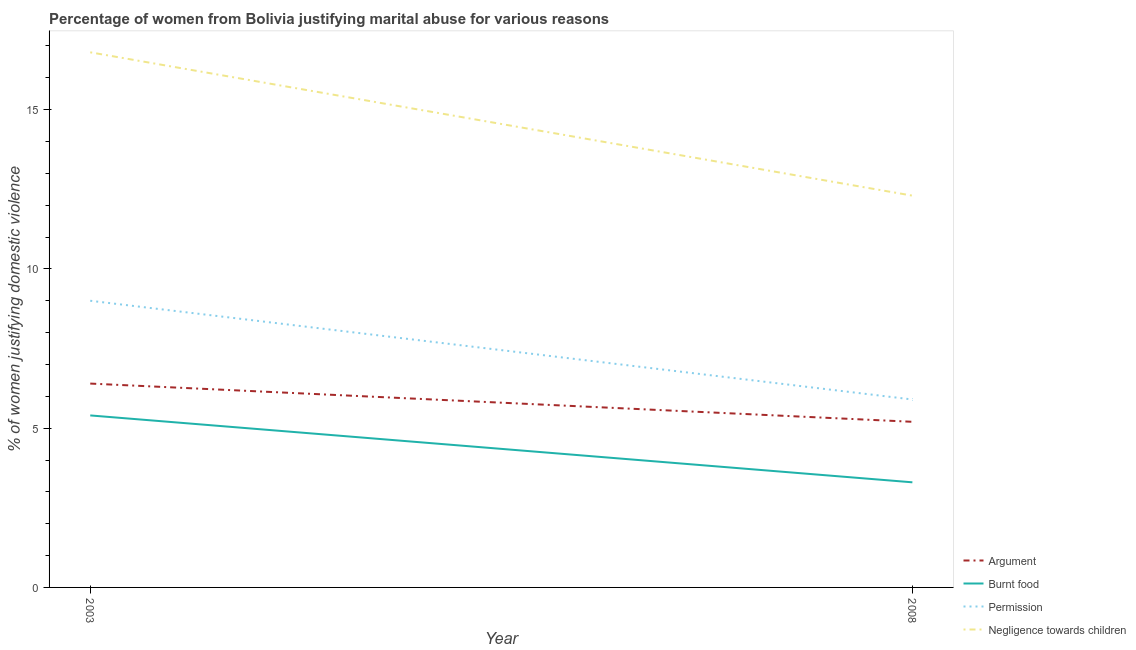How many different coloured lines are there?
Your answer should be very brief. 4. What is the percentage of women justifying abuse in the case of an argument in 2003?
Make the answer very short. 6.4. Across all years, what is the minimum percentage of women justifying abuse for showing negligence towards children?
Your answer should be compact. 12.3. What is the total percentage of women justifying abuse for showing negligence towards children in the graph?
Ensure brevity in your answer.  29.1. What is the difference between the percentage of women justifying abuse for going without permission in 2003 and that in 2008?
Your answer should be compact. 3.1. What is the difference between the percentage of women justifying abuse for going without permission in 2008 and the percentage of women justifying abuse for showing negligence towards children in 2003?
Provide a short and direct response. -10.9. What is the average percentage of women justifying abuse for showing negligence towards children per year?
Provide a short and direct response. 14.55. In the year 2003, what is the difference between the percentage of women justifying abuse for going without permission and percentage of women justifying abuse for burning food?
Give a very brief answer. 3.6. What is the ratio of the percentage of women justifying abuse for going without permission in 2003 to that in 2008?
Provide a short and direct response. 1.53. In how many years, is the percentage of women justifying abuse for burning food greater than the average percentage of women justifying abuse for burning food taken over all years?
Your response must be concise. 1. Is it the case that in every year, the sum of the percentage of women justifying abuse for going without permission and percentage of women justifying abuse for burning food is greater than the sum of percentage of women justifying abuse for showing negligence towards children and percentage of women justifying abuse in the case of an argument?
Ensure brevity in your answer.  No. Is the percentage of women justifying abuse for burning food strictly greater than the percentage of women justifying abuse for showing negligence towards children over the years?
Give a very brief answer. No. Does the graph contain any zero values?
Ensure brevity in your answer.  No. Does the graph contain grids?
Provide a succinct answer. No. Where does the legend appear in the graph?
Offer a very short reply. Bottom right. How many legend labels are there?
Your answer should be compact. 4. How are the legend labels stacked?
Your answer should be very brief. Vertical. What is the title of the graph?
Ensure brevity in your answer.  Percentage of women from Bolivia justifying marital abuse for various reasons. What is the label or title of the Y-axis?
Keep it short and to the point. % of women justifying domestic violence. What is the % of women justifying domestic violence in Permission in 2003?
Offer a terse response. 9. What is the % of women justifying domestic violence of Negligence towards children in 2003?
Your response must be concise. 16.8. What is the % of women justifying domestic violence in Argument in 2008?
Your answer should be very brief. 5.2. What is the % of women justifying domestic violence of Permission in 2008?
Your answer should be compact. 5.9. What is the % of women justifying domestic violence of Negligence towards children in 2008?
Offer a very short reply. 12.3. Across all years, what is the maximum % of women justifying domestic violence in Negligence towards children?
Offer a very short reply. 16.8. Across all years, what is the minimum % of women justifying domestic violence of Burnt food?
Offer a terse response. 3.3. What is the total % of women justifying domestic violence of Argument in the graph?
Give a very brief answer. 11.6. What is the total % of women justifying domestic violence in Burnt food in the graph?
Offer a terse response. 8.7. What is the total % of women justifying domestic violence of Permission in the graph?
Your answer should be very brief. 14.9. What is the total % of women justifying domestic violence of Negligence towards children in the graph?
Make the answer very short. 29.1. What is the difference between the % of women justifying domestic violence of Permission in 2003 and that in 2008?
Make the answer very short. 3.1. What is the difference between the % of women justifying domestic violence in Negligence towards children in 2003 and that in 2008?
Ensure brevity in your answer.  4.5. What is the difference between the % of women justifying domestic violence in Burnt food in 2003 and the % of women justifying domestic violence in Permission in 2008?
Your answer should be very brief. -0.5. What is the difference between the % of women justifying domestic violence in Burnt food in 2003 and the % of women justifying domestic violence in Negligence towards children in 2008?
Keep it short and to the point. -6.9. What is the average % of women justifying domestic violence in Burnt food per year?
Offer a very short reply. 4.35. What is the average % of women justifying domestic violence of Permission per year?
Offer a very short reply. 7.45. What is the average % of women justifying domestic violence in Negligence towards children per year?
Ensure brevity in your answer.  14.55. In the year 2003, what is the difference between the % of women justifying domestic violence of Argument and % of women justifying domestic violence of Permission?
Provide a succinct answer. -2.6. In the year 2003, what is the difference between the % of women justifying domestic violence in Burnt food and % of women justifying domestic violence in Permission?
Offer a very short reply. -3.6. In the year 2003, what is the difference between the % of women justifying domestic violence of Burnt food and % of women justifying domestic violence of Negligence towards children?
Your answer should be very brief. -11.4. In the year 2008, what is the difference between the % of women justifying domestic violence of Argument and % of women justifying domestic violence of Burnt food?
Your answer should be compact. 1.9. In the year 2008, what is the difference between the % of women justifying domestic violence of Argument and % of women justifying domestic violence of Permission?
Keep it short and to the point. -0.7. In the year 2008, what is the difference between the % of women justifying domestic violence of Burnt food and % of women justifying domestic violence of Permission?
Keep it short and to the point. -2.6. In the year 2008, what is the difference between the % of women justifying domestic violence of Burnt food and % of women justifying domestic violence of Negligence towards children?
Provide a short and direct response. -9. In the year 2008, what is the difference between the % of women justifying domestic violence of Permission and % of women justifying domestic violence of Negligence towards children?
Ensure brevity in your answer.  -6.4. What is the ratio of the % of women justifying domestic violence of Argument in 2003 to that in 2008?
Keep it short and to the point. 1.23. What is the ratio of the % of women justifying domestic violence in Burnt food in 2003 to that in 2008?
Your answer should be very brief. 1.64. What is the ratio of the % of women justifying domestic violence of Permission in 2003 to that in 2008?
Your answer should be very brief. 1.53. What is the ratio of the % of women justifying domestic violence of Negligence towards children in 2003 to that in 2008?
Your answer should be compact. 1.37. What is the difference between the highest and the lowest % of women justifying domestic violence in Burnt food?
Make the answer very short. 2.1. What is the difference between the highest and the lowest % of women justifying domestic violence in Permission?
Offer a terse response. 3.1. 